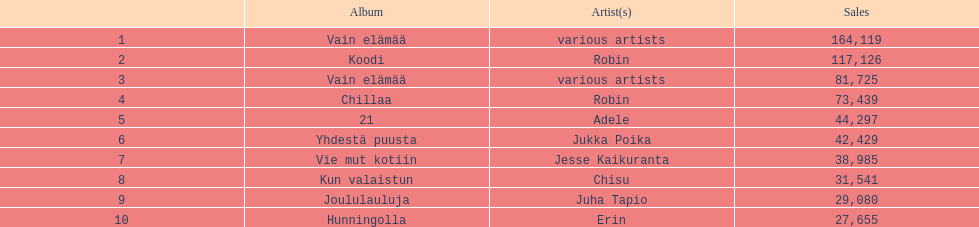Which one had better sales performance, hunningolla or vain elamaa? Vain elämää. 